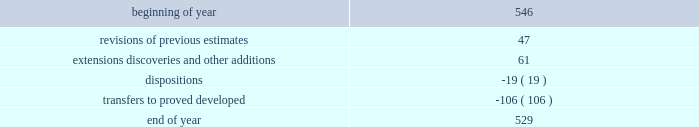Supplementary information on oil and gas producing activities ( unaudited ) 2018 proved reserves decreased by 168 mmboe primarily due to the following : 2022 revisions of previous estimates : increased by 84 mmboe including an increase of 108 mmboe associated with the acceleration of higher economic wells in the u.s .
Resource plays into the 5-year plan and an increase of 15 mmboe associated with wells to sales that were additions to the plan , partially offset by a decrease of 39 mmboe due to technical revisions across the business .
2022 extensions , discoveries , and other additions : increased by 102 mmboe primarily in the u.s .
Resource plays due to an increase of 69 mmboe associated with the expansion of proved areas and an increase of 33 mmboe associated with wells to sales from unproved categories .
2022 production : decreased by 153 mmboe .
2022 sales of reserves in place : decreased by 201 mmboe including 196 mmboe associated with the sale of our subsidiary in libya , 4 mmboe associated with divestitures of certain conventional assets in new mexico and michigan , and 1 mmboe associated with the sale of the sarsang block in kurdistan .
2017 proved reserves decreased by 647 mmboe primarily due to the following : 2022 revisions of previous estimates : increased by 49 mmboe primarily due to the acceleration of higher economic wells in the bakken into the 5-year plan resulting in an increase of 44 mmboe , with the remainder being due to revisions across the business .
2022 extensions , discoveries , and other additions : increased by 116 mmboe primarily due to an increase of 97 mmboe associated with the expansion of proved areas and wells to sales from unproved categories in oklahoma .
2022 purchases of reserves in place : increased by 28 mmboe from acquisitions of assets in the northern delaware basin in new mexico .
2022 production : decreased by 145 mmboe .
2022 sales of reserves in place : decreased by 695 mmboe including 685 mmboe associated with the sale of our canadian business and 10 mmboe associated with divestitures of certain conventional assets in oklahoma and colorado .
See item 8 .
Financial statements and supplementary data - note 5 to the consolidated financial statements for information regarding these dispositions .
2016 proved reserves decreased by 67 mmboe primarily due to the following : 2022 revisions of previous estimates : increased by 63 mmboe primarily due to an increase of 151 mmboe associated with the acceleration of higher economic wells in the u.s .
Resource plays into the 5-year plan and a decrease of 64 mmboe due to u.s .
Technical revisions .
2022 extensions , discoveries , and other additions : increased by 60 mmboe primarily associated with the expansion of proved areas and new wells to sales from unproven categories in oklahoma .
2022 purchases of reserves in place : increased by 34 mmboe from acquisition of stack assets in oklahoma .
2022 production : decreased by 144 mmboe .
2022 sales of reserves in place : decreased by 84 mmboe associated with the divestitures of certain wyoming and gulf of mexico assets .
Changes in proved undeveloped reserves as of december 31 , 2018 , 529 mmboe of proved undeveloped reserves were reported , a decrease of 17 mmboe from december 31 , 2017 .
The table shows changes in proved undeveloped reserves for 2018 : ( mmboe ) .

What percentage decrease of proved undeveloped reserves occurred during 2018? 
Computations: (17 / 546)
Answer: 0.03114. 